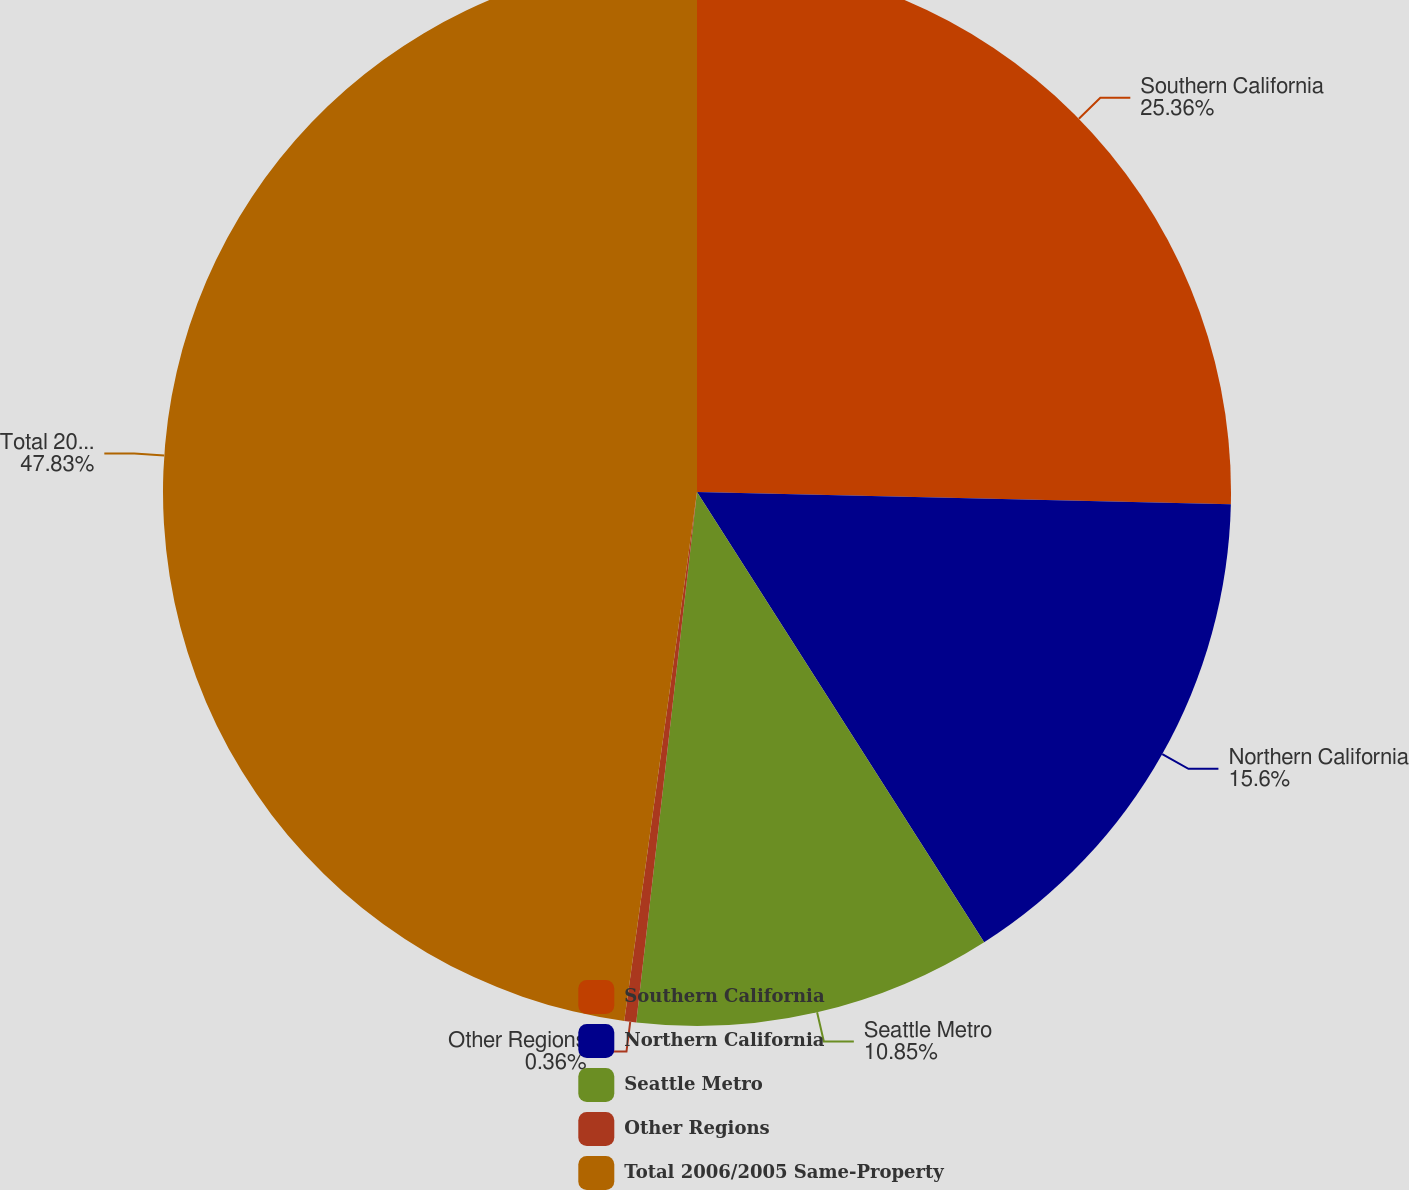Convert chart. <chart><loc_0><loc_0><loc_500><loc_500><pie_chart><fcel>Southern California<fcel>Northern California<fcel>Seattle Metro<fcel>Other Regions<fcel>Total 2006/2005 Same-Property<nl><fcel>25.36%<fcel>15.6%<fcel>10.85%<fcel>0.36%<fcel>47.82%<nl></chart> 